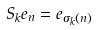<formula> <loc_0><loc_0><loc_500><loc_500>S _ { k } e _ { n } = e _ { \sigma _ { k } \left ( n \right ) }</formula> 